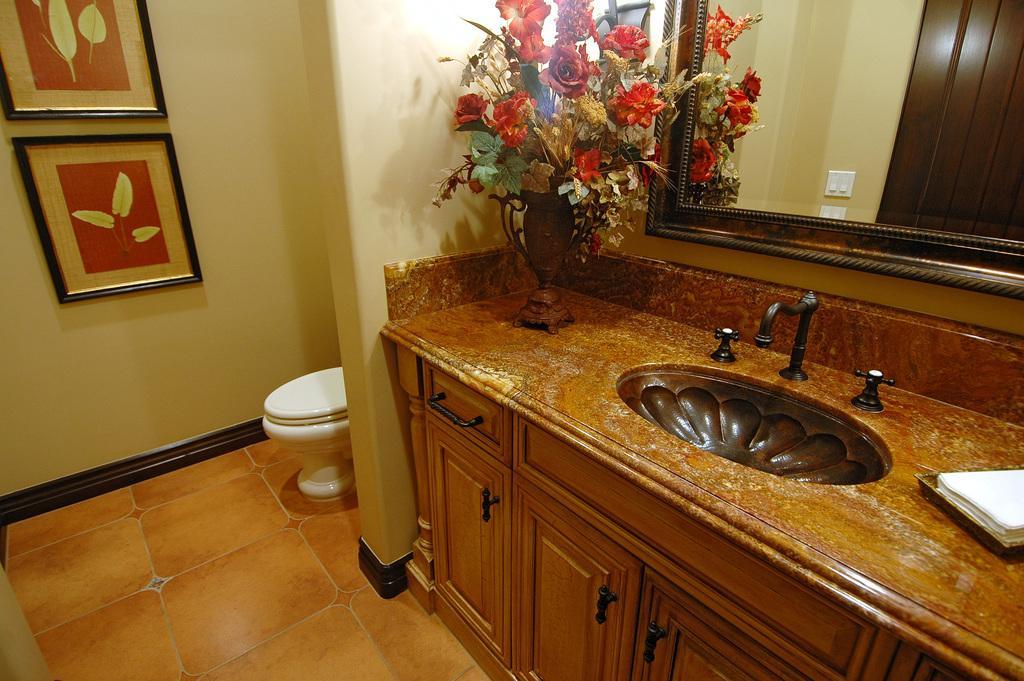In one or two sentences, can you explain what this image depicts? On the right side there is a table. Below the table there are drawers. On the table there is a wash basin with taps. Also there are tissues on a tray. On the corner there is a vase with flowers. On the wall there is a mirror. In the back there are photo frames. On the mirror there is a reflection of socket. 